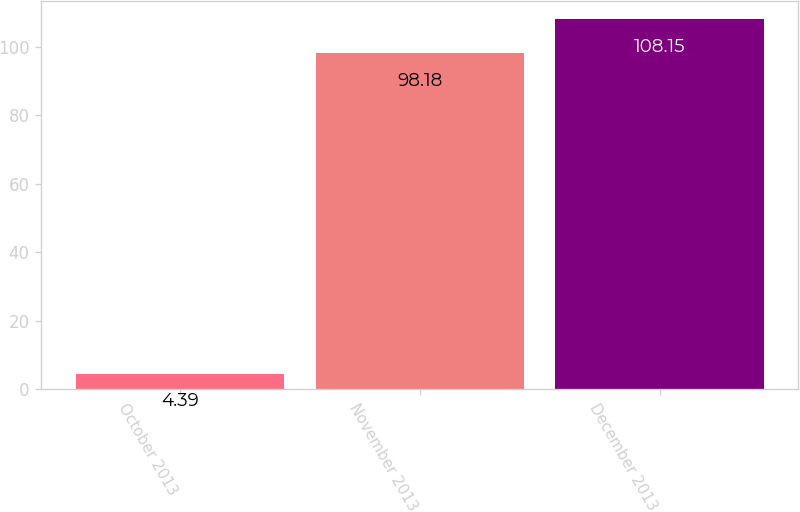Convert chart. <chart><loc_0><loc_0><loc_500><loc_500><bar_chart><fcel>October 2013<fcel>November 2013<fcel>December 2013<nl><fcel>4.39<fcel>98.18<fcel>108.15<nl></chart> 